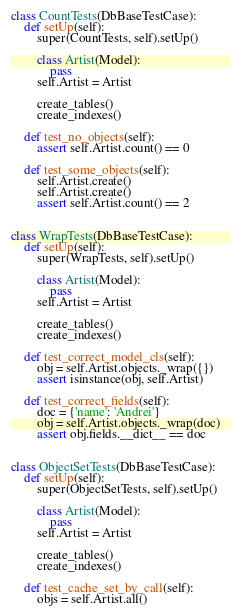<code> <loc_0><loc_0><loc_500><loc_500><_Python_>

class CountTests(DbBaseTestCase):
    def setUp(self):
        super(CountTests, self).setUp()

        class Artist(Model):
            pass
        self.Artist = Artist

        create_tables()
        create_indexes()

    def test_no_objects(self):
        assert self.Artist.count() == 0

    def test_some_objects(self):
        self.Artist.create()
        self.Artist.create()
        assert self.Artist.count() == 2


class WrapTests(DbBaseTestCase):
    def setUp(self):
        super(WrapTests, self).setUp()

        class Artist(Model):
            pass
        self.Artist = Artist

        create_tables()
        create_indexes()

    def test_correct_model_cls(self):
        obj = self.Artist.objects._wrap({})
        assert isinstance(obj, self.Artist)

    def test_correct_fields(self):
        doc = {'name': 'Andrei'}
        obj = self.Artist.objects._wrap(doc)
        assert obj.fields.__dict__ == doc


class ObjectSetTests(DbBaseTestCase):
    def setUp(self):
        super(ObjectSetTests, self).setUp()

        class Artist(Model):
            pass
        self.Artist = Artist

        create_tables()
        create_indexes()

    def test_cache_set_by_call(self):
        objs = self.Artist.all()</code> 